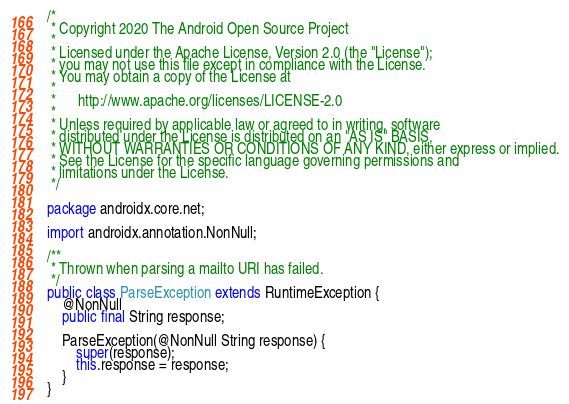Convert code to text. <code><loc_0><loc_0><loc_500><loc_500><_Java_>/*
 * Copyright 2020 The Android Open Source Project
 *
 * Licensed under the Apache License, Version 2.0 (the "License");
 * you may not use this file except in compliance with the License.
 * You may obtain a copy of the License at
 *
 *      http://www.apache.org/licenses/LICENSE-2.0
 *
 * Unless required by applicable law or agreed to in writing, software
 * distributed under the License is distributed on an "AS IS" BASIS,
 * WITHOUT WARRANTIES OR CONDITIONS OF ANY KIND, either express or implied.
 * See the License for the specific language governing permissions and
 * limitations under the License.
 */

package androidx.core.net;

import androidx.annotation.NonNull;

/**
 * Thrown when parsing a mailto URI has failed.
 */
public class ParseException extends RuntimeException {
    @NonNull
    public final String response;

    ParseException(@NonNull String response) {
        super(response);
        this.response = response;
    }
}
</code> 